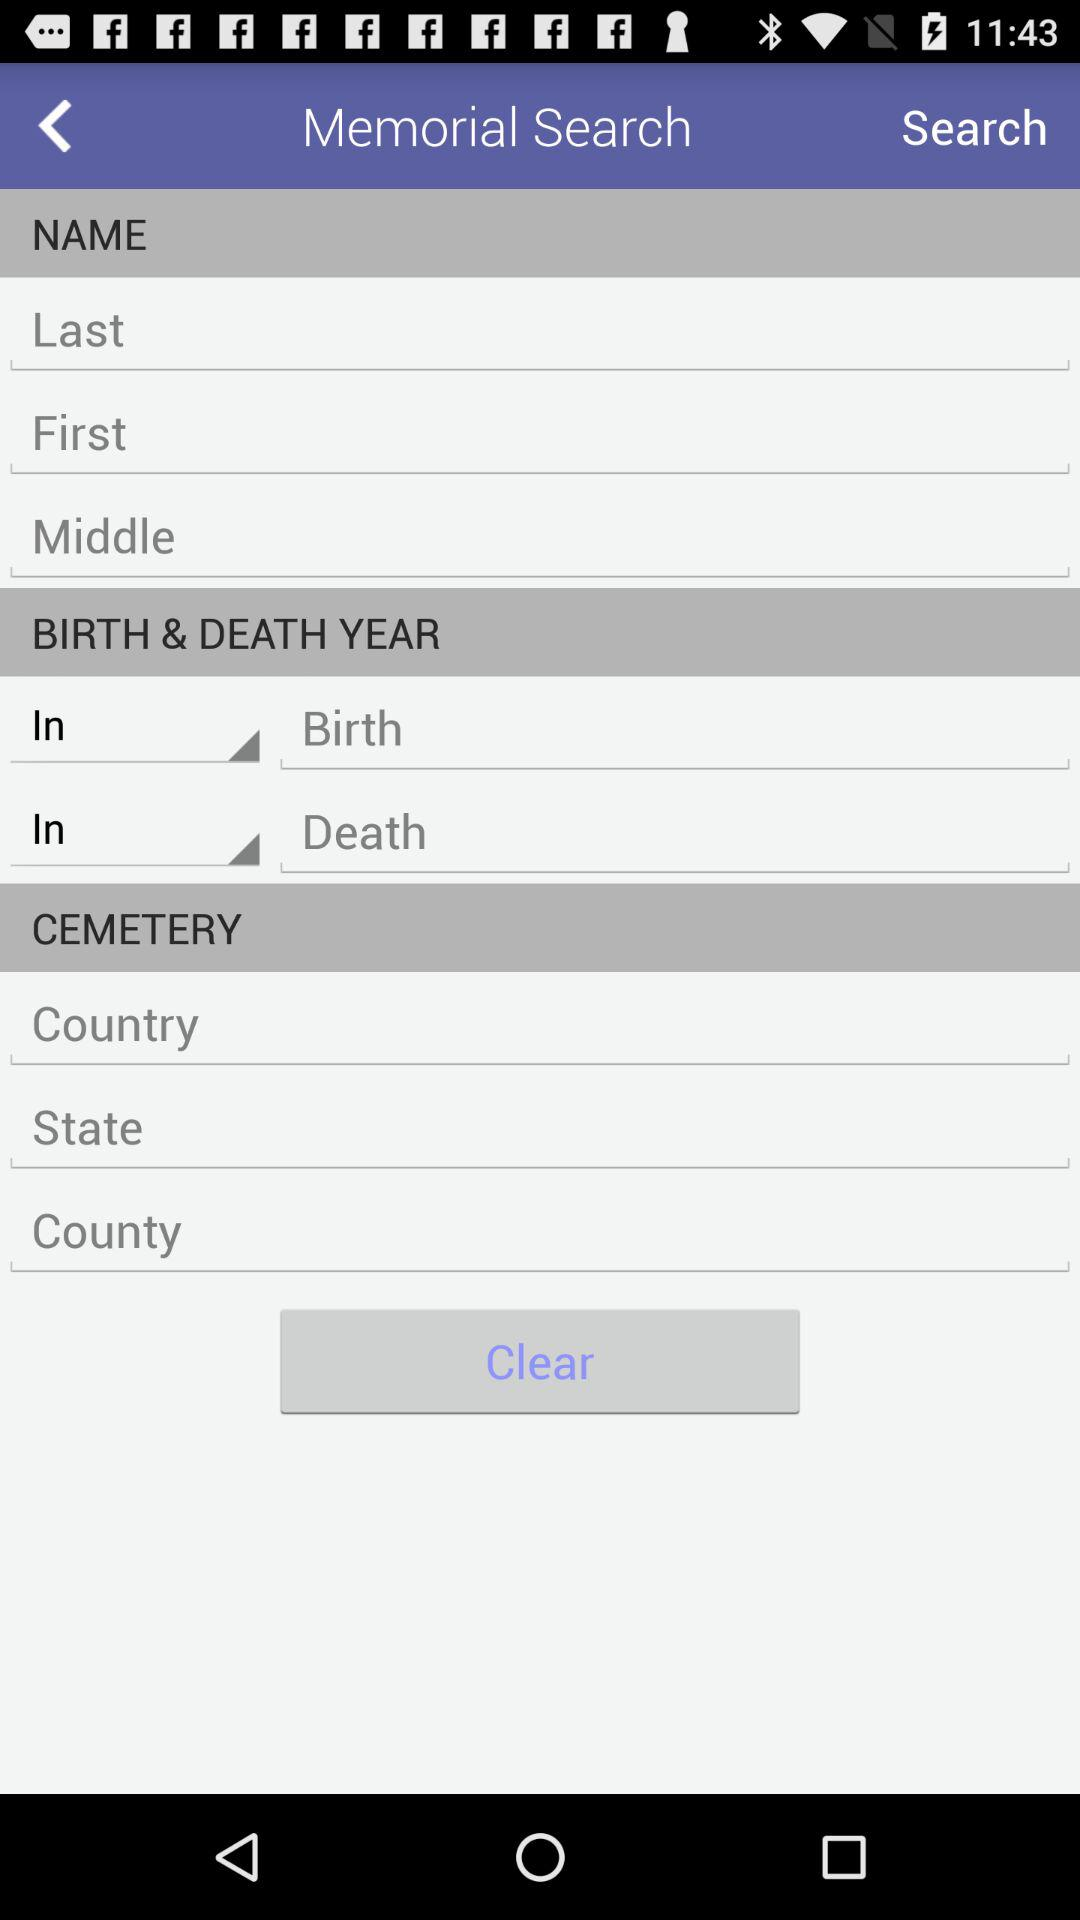How many text inputs are there for first, middle, and last names?
Answer the question using a single word or phrase. 3 